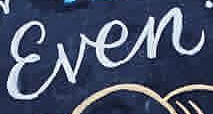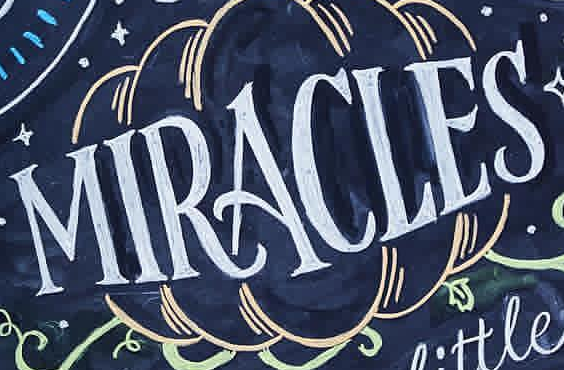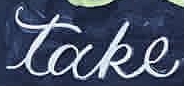What words can you see in these images in sequence, separated by a semicolon? Ɛven; MIRACLES; take 